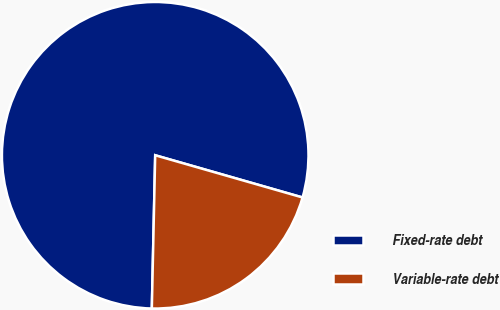Convert chart. <chart><loc_0><loc_0><loc_500><loc_500><pie_chart><fcel>Fixed-rate debt<fcel>Variable-rate debt<nl><fcel>79.09%<fcel>20.91%<nl></chart> 